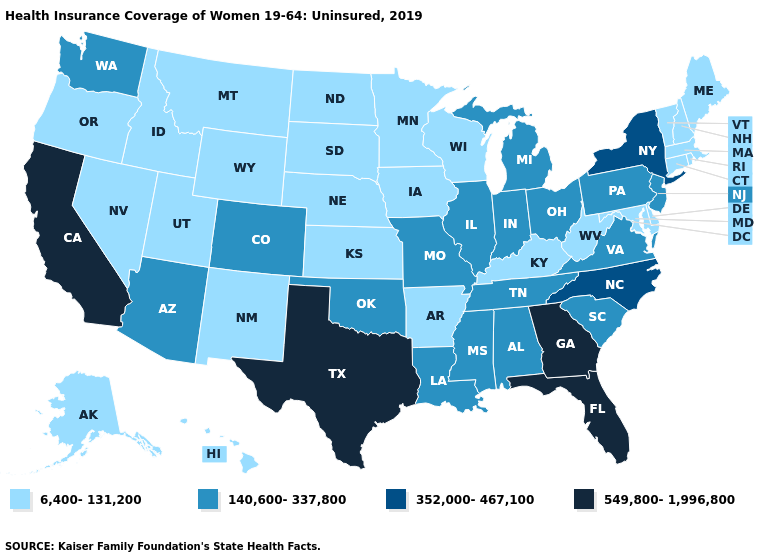What is the lowest value in the Northeast?
Be succinct. 6,400-131,200. Name the states that have a value in the range 6,400-131,200?
Give a very brief answer. Alaska, Arkansas, Connecticut, Delaware, Hawaii, Idaho, Iowa, Kansas, Kentucky, Maine, Maryland, Massachusetts, Minnesota, Montana, Nebraska, Nevada, New Hampshire, New Mexico, North Dakota, Oregon, Rhode Island, South Dakota, Utah, Vermont, West Virginia, Wisconsin, Wyoming. Name the states that have a value in the range 6,400-131,200?
Give a very brief answer. Alaska, Arkansas, Connecticut, Delaware, Hawaii, Idaho, Iowa, Kansas, Kentucky, Maine, Maryland, Massachusetts, Minnesota, Montana, Nebraska, Nevada, New Hampshire, New Mexico, North Dakota, Oregon, Rhode Island, South Dakota, Utah, Vermont, West Virginia, Wisconsin, Wyoming. Does the first symbol in the legend represent the smallest category?
Short answer required. Yes. Does Missouri have a lower value than Georgia?
Be succinct. Yes. Among the states that border Iowa , does Nebraska have the lowest value?
Write a very short answer. Yes. What is the value of New Jersey?
Keep it brief. 140,600-337,800. What is the highest value in the South ?
Short answer required. 549,800-1,996,800. Name the states that have a value in the range 140,600-337,800?
Be succinct. Alabama, Arizona, Colorado, Illinois, Indiana, Louisiana, Michigan, Mississippi, Missouri, New Jersey, Ohio, Oklahoma, Pennsylvania, South Carolina, Tennessee, Virginia, Washington. Name the states that have a value in the range 352,000-467,100?
Keep it brief. New York, North Carolina. What is the value of Rhode Island?
Give a very brief answer. 6,400-131,200. Does the map have missing data?
Be succinct. No. What is the highest value in the USA?
Short answer required. 549,800-1,996,800. Does New York have the lowest value in the Northeast?
Be succinct. No. Name the states that have a value in the range 352,000-467,100?
Keep it brief. New York, North Carolina. 